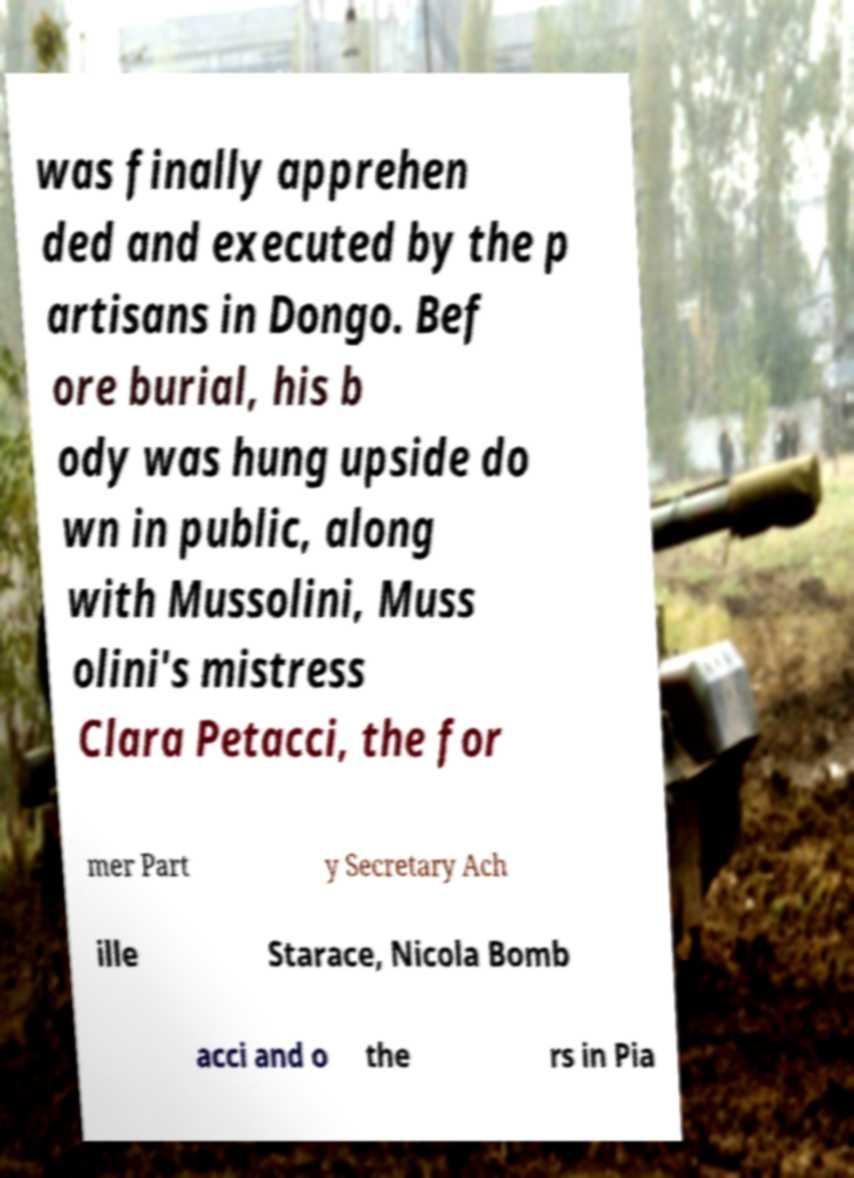What messages or text are displayed in this image? I need them in a readable, typed format. was finally apprehen ded and executed by the p artisans in Dongo. Bef ore burial, his b ody was hung upside do wn in public, along with Mussolini, Muss olini's mistress Clara Petacci, the for mer Part y Secretary Ach ille Starace, Nicola Bomb acci and o the rs in Pia 